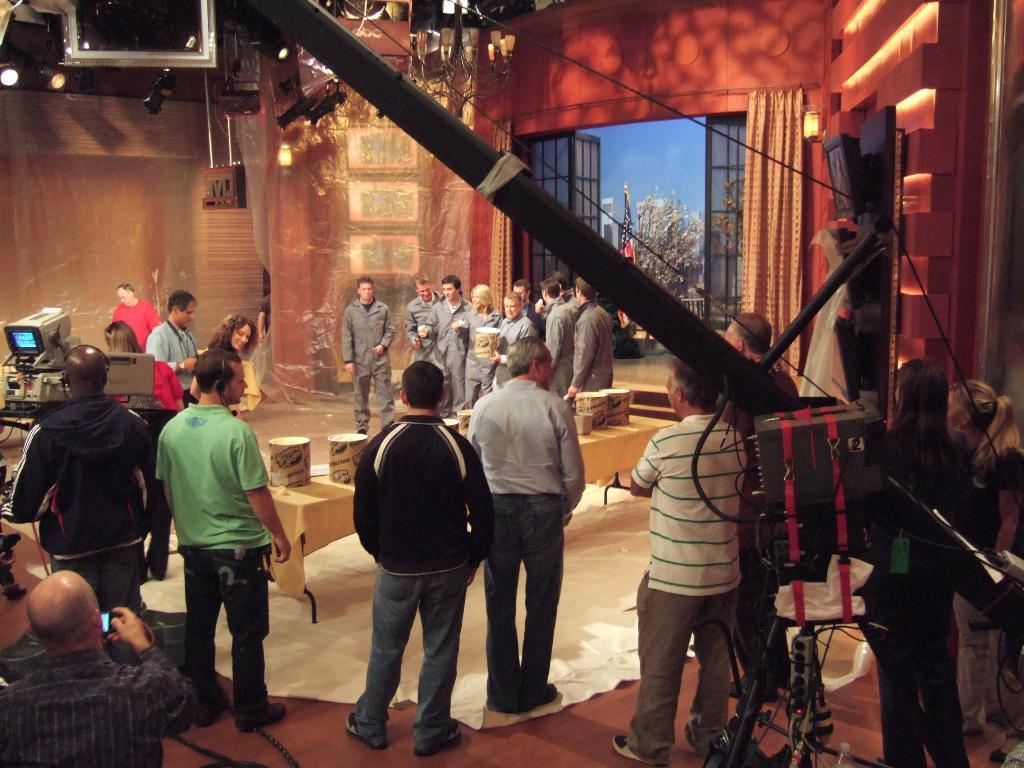How many men are present in the image? There are many men standing in the image. Where are the men standing? The men are standing on the floor. What can be seen in the middle of the image? There is a table in the middle of the image. What object is present that is typically used for capturing images? There is a camera with a screen on the front in the image. What type of scene is being shot, based on the presence of the camera and the men? The scene appears to be a cinema shooting. What word is being shouted during the fight in the image? There is no fight present in the image, and therefore no shouting or words can be observed. What type of badge is being worn by the men in the image? There is no mention of badges being worn by the men in the image. 